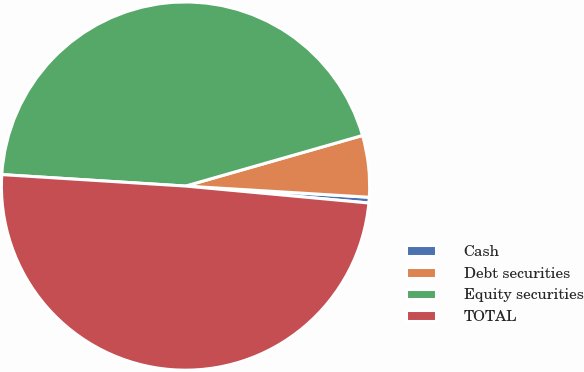Convert chart. <chart><loc_0><loc_0><loc_500><loc_500><pie_chart><fcel>Cash<fcel>Debt securities<fcel>Equity securities<fcel>TOTAL<nl><fcel>0.5%<fcel>5.4%<fcel>44.58%<fcel>49.53%<nl></chart> 